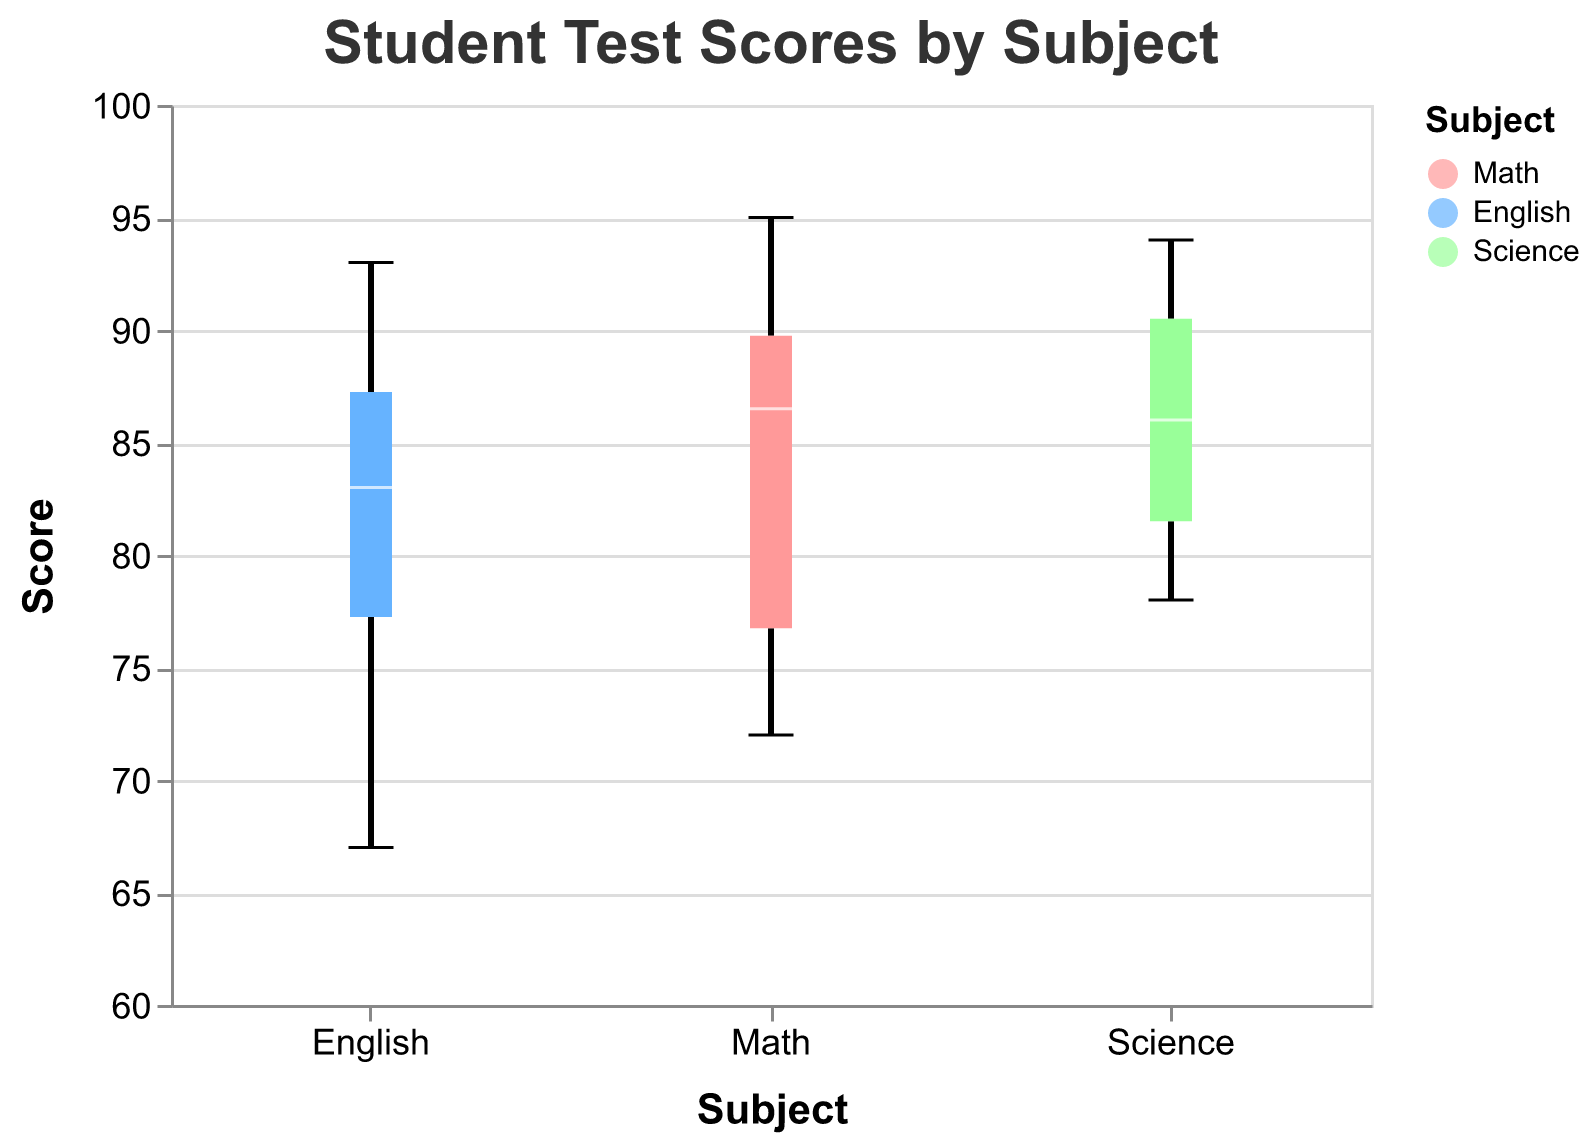What is the title of the box plot? The title of the box plot is generally found at the top of the figure and summarizes the content visually represented. The title is "Student Test Scores by Subject".
Answer: Student Test Scores by Subject Which subject has the highest median score? To find the highest median score, look at the middle line in each box plot. The median line is represented in white. Compare the positions of these lines across Math, English, and Science.
Answer: Science What is the range of scores for the subject of Math? The range can be determined by subtracting the minimum score from the maximum score in the box plot for Math. Look at the vertical lines (whiskers) extending from the upper and lower edges of the box in the Math plot. The minimum score is 72 and the maximum is 95. Therefore, the range is 95 - 72.
Answer: 23 Which subject has the largest interquartile range (IQR)? The interquartile range (IQR) is the difference between the upper quartile (top edge of the box) and the lower quartile (bottom edge of the box). Visualize the length of the boxes in Math, English, and Science. The longest box represents the largest IQR.
Answer: English What is the lowest score in English and which student scored it? To find the lowest score, look at the bottom whisker of the English box plot. It is at 67. Refer to the list of data points; Fiona scored 67 in English.
Answer: Fiona, 67 Compare the median scores of Math and English. Which one is higher and by how much? The median is the white line in each box plot. Estimate the positions of the medians for Math and English. Math has a median of approximately 85 and English approximately 84, so Math is higher. The difference is 85 - 84.
Answer: Math by 1 How many subjects have outliers? Outliers are typically represented by dots outside of the whiskers. Examine each subject's box plot to count how many subjects have dots outside of their whiskers. Math, English, and Science do not show any outliers.
Answer: 0 subjects Which subject has the smallest number of scores below 80? Compare the position of the lower edges of the boxes (marks the first quartile) across all subjects. The box with the highest lower edge will have the smallest number of scores below 80.
Answer: Science What is the difference between the maximum and Q3 (upper quartile) for the Science subject? The maximum value is the top whisker, and Q3 is the top edge of the box. For Science, these values are 94 and 89 respectively. Subtract these values: 94 - 89.
Answer: 5 